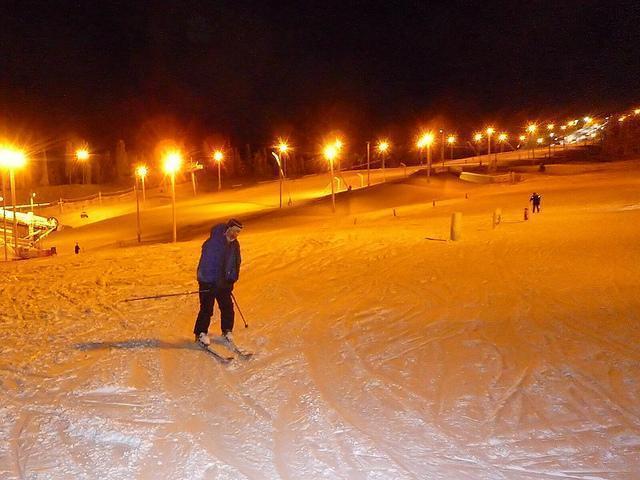Why is there so much orange in this image?
Select the accurate response from the four choices given to answer the question.
Options: Sunset, orange filter, orange lights, sunrise. Orange lights. 